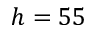Convert formula to latex. <formula><loc_0><loc_0><loc_500><loc_500>h = 5 5</formula> 